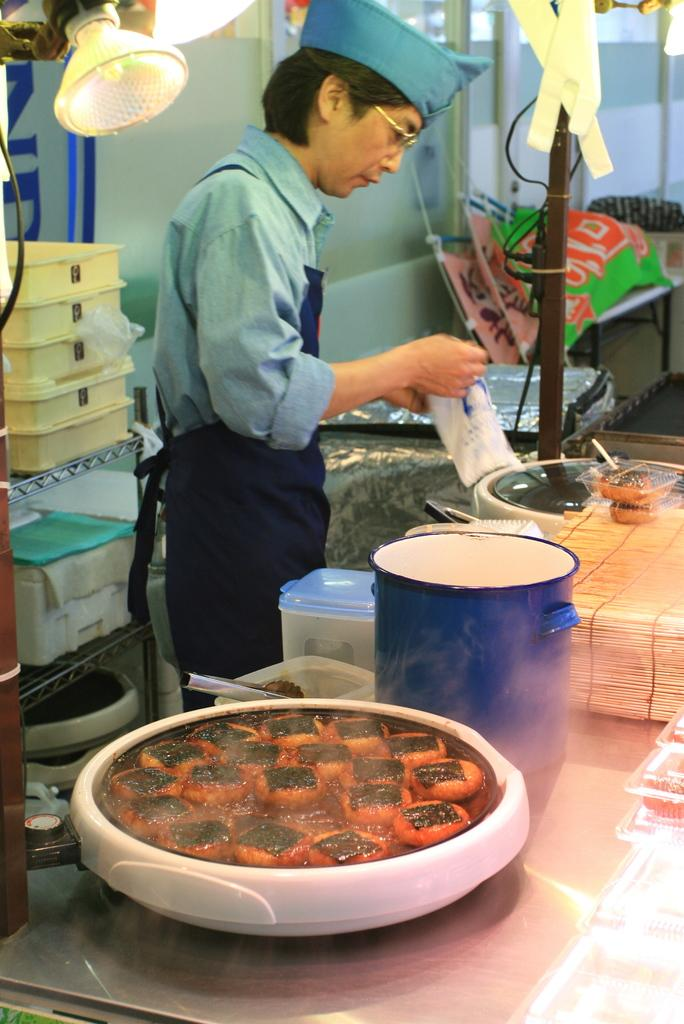What is the person in the image holding? There is a person holding something in the image, but the specific object is not mentioned in the facts. What types of vehicles can be seen in the image? There are vehicles visible in the image, but the specific types are not mentioned in the facts. What objects are on the table in the image? There are objects on a table in the image, but the specific objects are not mentioned in the facts. What can be seen in the background of the image? In the background of the image, there is a wall and objects on racks, but the specific objects on the racks are not mentioned in the facts. How many pigs are visible on the person's suit in the image? There are no pigs or suits mentioned in the image, so this question cannot be answered definitively. 